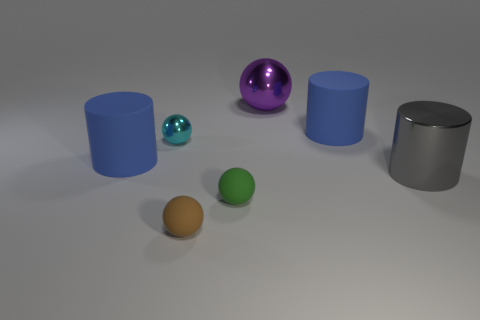What number of things are cyan metallic balls or blue rubber cylinders?
Provide a short and direct response. 3. Is there a large purple cube?
Provide a succinct answer. No. Are there fewer large balls than small purple shiny blocks?
Your answer should be very brief. No. Are there any gray things of the same size as the purple thing?
Your answer should be very brief. Yes. There is a green object; is its shape the same as the large blue rubber thing to the left of the small brown sphere?
Your response must be concise. No. How many spheres are large red metal objects or purple objects?
Provide a short and direct response. 1. What color is the shiny cylinder?
Offer a terse response. Gray. Are there more purple rubber things than gray objects?
Keep it short and to the point. No. What number of things are blue matte cylinders right of the purple sphere or green matte spheres?
Make the answer very short. 2. Is the large sphere made of the same material as the gray cylinder?
Your answer should be compact. Yes. 